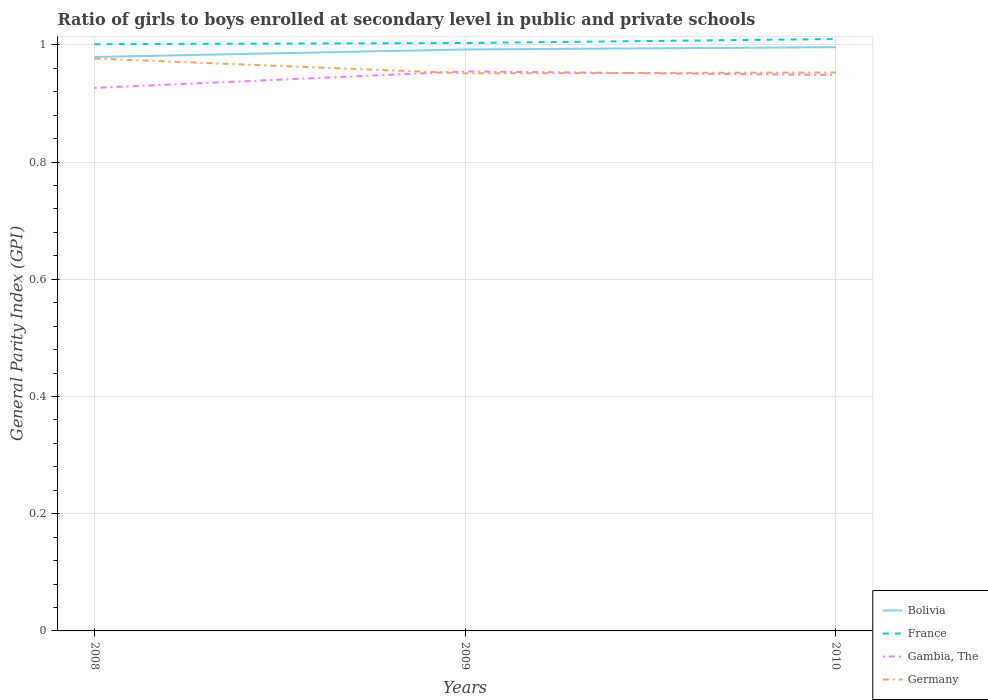Does the line corresponding to Bolivia intersect with the line corresponding to France?
Your answer should be compact. No. Is the number of lines equal to the number of legend labels?
Provide a succinct answer. Yes. Across all years, what is the maximum general parity index in Bolivia?
Keep it short and to the point. 0.98. In which year was the general parity index in Germany maximum?
Keep it short and to the point. 2009. What is the total general parity index in Bolivia in the graph?
Ensure brevity in your answer.  -0. What is the difference between the highest and the second highest general parity index in Gambia, The?
Your answer should be compact. 0.03. How many years are there in the graph?
Provide a short and direct response. 3. Does the graph contain any zero values?
Offer a terse response. No. How many legend labels are there?
Provide a short and direct response. 4. What is the title of the graph?
Give a very brief answer. Ratio of girls to boys enrolled at secondary level in public and private schools. Does "Yemen, Rep." appear as one of the legend labels in the graph?
Your answer should be compact. No. What is the label or title of the X-axis?
Provide a short and direct response. Years. What is the label or title of the Y-axis?
Provide a succinct answer. General Parity Index (GPI). What is the General Parity Index (GPI) in Bolivia in 2008?
Provide a succinct answer. 0.98. What is the General Parity Index (GPI) of France in 2008?
Your response must be concise. 1. What is the General Parity Index (GPI) of Gambia, The in 2008?
Provide a short and direct response. 0.93. What is the General Parity Index (GPI) of Germany in 2008?
Your response must be concise. 0.98. What is the General Parity Index (GPI) in Bolivia in 2009?
Your answer should be compact. 0.99. What is the General Parity Index (GPI) in France in 2009?
Provide a short and direct response. 1. What is the General Parity Index (GPI) of Gambia, The in 2009?
Provide a succinct answer. 0.95. What is the General Parity Index (GPI) of Germany in 2009?
Provide a short and direct response. 0.95. What is the General Parity Index (GPI) of Bolivia in 2010?
Your response must be concise. 1. What is the General Parity Index (GPI) in France in 2010?
Offer a very short reply. 1.01. What is the General Parity Index (GPI) in Gambia, The in 2010?
Your response must be concise. 0.95. What is the General Parity Index (GPI) in Germany in 2010?
Ensure brevity in your answer.  0.95. Across all years, what is the maximum General Parity Index (GPI) of Bolivia?
Make the answer very short. 1. Across all years, what is the maximum General Parity Index (GPI) in France?
Your answer should be compact. 1.01. Across all years, what is the maximum General Parity Index (GPI) in Gambia, The?
Give a very brief answer. 0.95. Across all years, what is the maximum General Parity Index (GPI) in Germany?
Give a very brief answer. 0.98. Across all years, what is the minimum General Parity Index (GPI) of Bolivia?
Keep it short and to the point. 0.98. Across all years, what is the minimum General Parity Index (GPI) of France?
Give a very brief answer. 1. Across all years, what is the minimum General Parity Index (GPI) of Gambia, The?
Make the answer very short. 0.93. Across all years, what is the minimum General Parity Index (GPI) in Germany?
Give a very brief answer. 0.95. What is the total General Parity Index (GPI) in Bolivia in the graph?
Keep it short and to the point. 2.97. What is the total General Parity Index (GPI) in France in the graph?
Provide a succinct answer. 3.01. What is the total General Parity Index (GPI) of Gambia, The in the graph?
Provide a short and direct response. 2.83. What is the total General Parity Index (GPI) in Germany in the graph?
Offer a very short reply. 2.88. What is the difference between the General Parity Index (GPI) in Bolivia in 2008 and that in 2009?
Provide a short and direct response. -0.01. What is the difference between the General Parity Index (GPI) in France in 2008 and that in 2009?
Ensure brevity in your answer.  -0. What is the difference between the General Parity Index (GPI) in Gambia, The in 2008 and that in 2009?
Provide a succinct answer. -0.03. What is the difference between the General Parity Index (GPI) in Germany in 2008 and that in 2009?
Your answer should be very brief. 0.03. What is the difference between the General Parity Index (GPI) in Bolivia in 2008 and that in 2010?
Provide a short and direct response. -0.02. What is the difference between the General Parity Index (GPI) of France in 2008 and that in 2010?
Your answer should be very brief. -0.01. What is the difference between the General Parity Index (GPI) in Gambia, The in 2008 and that in 2010?
Offer a very short reply. -0.02. What is the difference between the General Parity Index (GPI) in Germany in 2008 and that in 2010?
Ensure brevity in your answer.  0.02. What is the difference between the General Parity Index (GPI) of Bolivia in 2009 and that in 2010?
Keep it short and to the point. -0. What is the difference between the General Parity Index (GPI) in France in 2009 and that in 2010?
Provide a succinct answer. -0.01. What is the difference between the General Parity Index (GPI) of Gambia, The in 2009 and that in 2010?
Ensure brevity in your answer.  0.01. What is the difference between the General Parity Index (GPI) of Germany in 2009 and that in 2010?
Your response must be concise. -0. What is the difference between the General Parity Index (GPI) in Bolivia in 2008 and the General Parity Index (GPI) in France in 2009?
Keep it short and to the point. -0.02. What is the difference between the General Parity Index (GPI) in Bolivia in 2008 and the General Parity Index (GPI) in Gambia, The in 2009?
Offer a terse response. 0.02. What is the difference between the General Parity Index (GPI) of Bolivia in 2008 and the General Parity Index (GPI) of Germany in 2009?
Give a very brief answer. 0.03. What is the difference between the General Parity Index (GPI) in France in 2008 and the General Parity Index (GPI) in Gambia, The in 2009?
Your answer should be compact. 0.05. What is the difference between the General Parity Index (GPI) in France in 2008 and the General Parity Index (GPI) in Germany in 2009?
Ensure brevity in your answer.  0.05. What is the difference between the General Parity Index (GPI) of Gambia, The in 2008 and the General Parity Index (GPI) of Germany in 2009?
Ensure brevity in your answer.  -0.02. What is the difference between the General Parity Index (GPI) in Bolivia in 2008 and the General Parity Index (GPI) in France in 2010?
Your answer should be very brief. -0.03. What is the difference between the General Parity Index (GPI) of Bolivia in 2008 and the General Parity Index (GPI) of Gambia, The in 2010?
Your answer should be compact. 0.03. What is the difference between the General Parity Index (GPI) in Bolivia in 2008 and the General Parity Index (GPI) in Germany in 2010?
Provide a short and direct response. 0.03. What is the difference between the General Parity Index (GPI) of France in 2008 and the General Parity Index (GPI) of Gambia, The in 2010?
Keep it short and to the point. 0.05. What is the difference between the General Parity Index (GPI) in France in 2008 and the General Parity Index (GPI) in Germany in 2010?
Your answer should be very brief. 0.05. What is the difference between the General Parity Index (GPI) of Gambia, The in 2008 and the General Parity Index (GPI) of Germany in 2010?
Your response must be concise. -0.03. What is the difference between the General Parity Index (GPI) of Bolivia in 2009 and the General Parity Index (GPI) of France in 2010?
Your answer should be very brief. -0.02. What is the difference between the General Parity Index (GPI) of Bolivia in 2009 and the General Parity Index (GPI) of Gambia, The in 2010?
Ensure brevity in your answer.  0.04. What is the difference between the General Parity Index (GPI) in Bolivia in 2009 and the General Parity Index (GPI) in Germany in 2010?
Provide a succinct answer. 0.04. What is the difference between the General Parity Index (GPI) of France in 2009 and the General Parity Index (GPI) of Gambia, The in 2010?
Make the answer very short. 0.05. What is the difference between the General Parity Index (GPI) in France in 2009 and the General Parity Index (GPI) in Germany in 2010?
Offer a very short reply. 0.05. What is the difference between the General Parity Index (GPI) in Gambia, The in 2009 and the General Parity Index (GPI) in Germany in 2010?
Provide a short and direct response. 0. What is the average General Parity Index (GPI) in Bolivia per year?
Give a very brief answer. 0.99. What is the average General Parity Index (GPI) of France per year?
Your answer should be compact. 1. What is the average General Parity Index (GPI) in Gambia, The per year?
Provide a short and direct response. 0.94. What is the average General Parity Index (GPI) of Germany per year?
Offer a terse response. 0.96. In the year 2008, what is the difference between the General Parity Index (GPI) of Bolivia and General Parity Index (GPI) of France?
Provide a succinct answer. -0.02. In the year 2008, what is the difference between the General Parity Index (GPI) in Bolivia and General Parity Index (GPI) in Gambia, The?
Provide a succinct answer. 0.05. In the year 2008, what is the difference between the General Parity Index (GPI) in Bolivia and General Parity Index (GPI) in Germany?
Your answer should be very brief. 0. In the year 2008, what is the difference between the General Parity Index (GPI) of France and General Parity Index (GPI) of Gambia, The?
Your answer should be very brief. 0.07. In the year 2008, what is the difference between the General Parity Index (GPI) of France and General Parity Index (GPI) of Germany?
Offer a terse response. 0.02. In the year 2009, what is the difference between the General Parity Index (GPI) in Bolivia and General Parity Index (GPI) in France?
Offer a very short reply. -0.01. In the year 2009, what is the difference between the General Parity Index (GPI) in Bolivia and General Parity Index (GPI) in Gambia, The?
Give a very brief answer. 0.04. In the year 2009, what is the difference between the General Parity Index (GPI) in Bolivia and General Parity Index (GPI) in Germany?
Your response must be concise. 0.04. In the year 2009, what is the difference between the General Parity Index (GPI) in France and General Parity Index (GPI) in Gambia, The?
Ensure brevity in your answer.  0.05. In the year 2009, what is the difference between the General Parity Index (GPI) of France and General Parity Index (GPI) of Germany?
Make the answer very short. 0.05. In the year 2009, what is the difference between the General Parity Index (GPI) of Gambia, The and General Parity Index (GPI) of Germany?
Provide a succinct answer. 0. In the year 2010, what is the difference between the General Parity Index (GPI) of Bolivia and General Parity Index (GPI) of France?
Offer a terse response. -0.01. In the year 2010, what is the difference between the General Parity Index (GPI) of Bolivia and General Parity Index (GPI) of Gambia, The?
Your answer should be compact. 0.05. In the year 2010, what is the difference between the General Parity Index (GPI) of Bolivia and General Parity Index (GPI) of Germany?
Offer a very short reply. 0.04. In the year 2010, what is the difference between the General Parity Index (GPI) of France and General Parity Index (GPI) of Gambia, The?
Offer a terse response. 0.06. In the year 2010, what is the difference between the General Parity Index (GPI) of France and General Parity Index (GPI) of Germany?
Provide a succinct answer. 0.06. In the year 2010, what is the difference between the General Parity Index (GPI) in Gambia, The and General Parity Index (GPI) in Germany?
Offer a terse response. -0. What is the ratio of the General Parity Index (GPI) of Gambia, The in 2008 to that in 2009?
Your answer should be very brief. 0.97. What is the ratio of the General Parity Index (GPI) of Germany in 2008 to that in 2009?
Offer a terse response. 1.03. What is the ratio of the General Parity Index (GPI) in Bolivia in 2008 to that in 2010?
Keep it short and to the point. 0.98. What is the ratio of the General Parity Index (GPI) of France in 2008 to that in 2010?
Your answer should be compact. 0.99. What is the ratio of the General Parity Index (GPI) in Gambia, The in 2008 to that in 2010?
Your answer should be very brief. 0.98. What is the ratio of the General Parity Index (GPI) in Germany in 2008 to that in 2010?
Provide a short and direct response. 1.03. What is the ratio of the General Parity Index (GPI) of Gambia, The in 2009 to that in 2010?
Offer a terse response. 1.01. What is the difference between the highest and the second highest General Parity Index (GPI) in Bolivia?
Offer a terse response. 0. What is the difference between the highest and the second highest General Parity Index (GPI) in France?
Offer a very short reply. 0.01. What is the difference between the highest and the second highest General Parity Index (GPI) of Gambia, The?
Offer a terse response. 0.01. What is the difference between the highest and the second highest General Parity Index (GPI) of Germany?
Give a very brief answer. 0.02. What is the difference between the highest and the lowest General Parity Index (GPI) in Bolivia?
Your answer should be very brief. 0.02. What is the difference between the highest and the lowest General Parity Index (GPI) in France?
Offer a terse response. 0.01. What is the difference between the highest and the lowest General Parity Index (GPI) of Gambia, The?
Keep it short and to the point. 0.03. What is the difference between the highest and the lowest General Parity Index (GPI) in Germany?
Your answer should be compact. 0.03. 